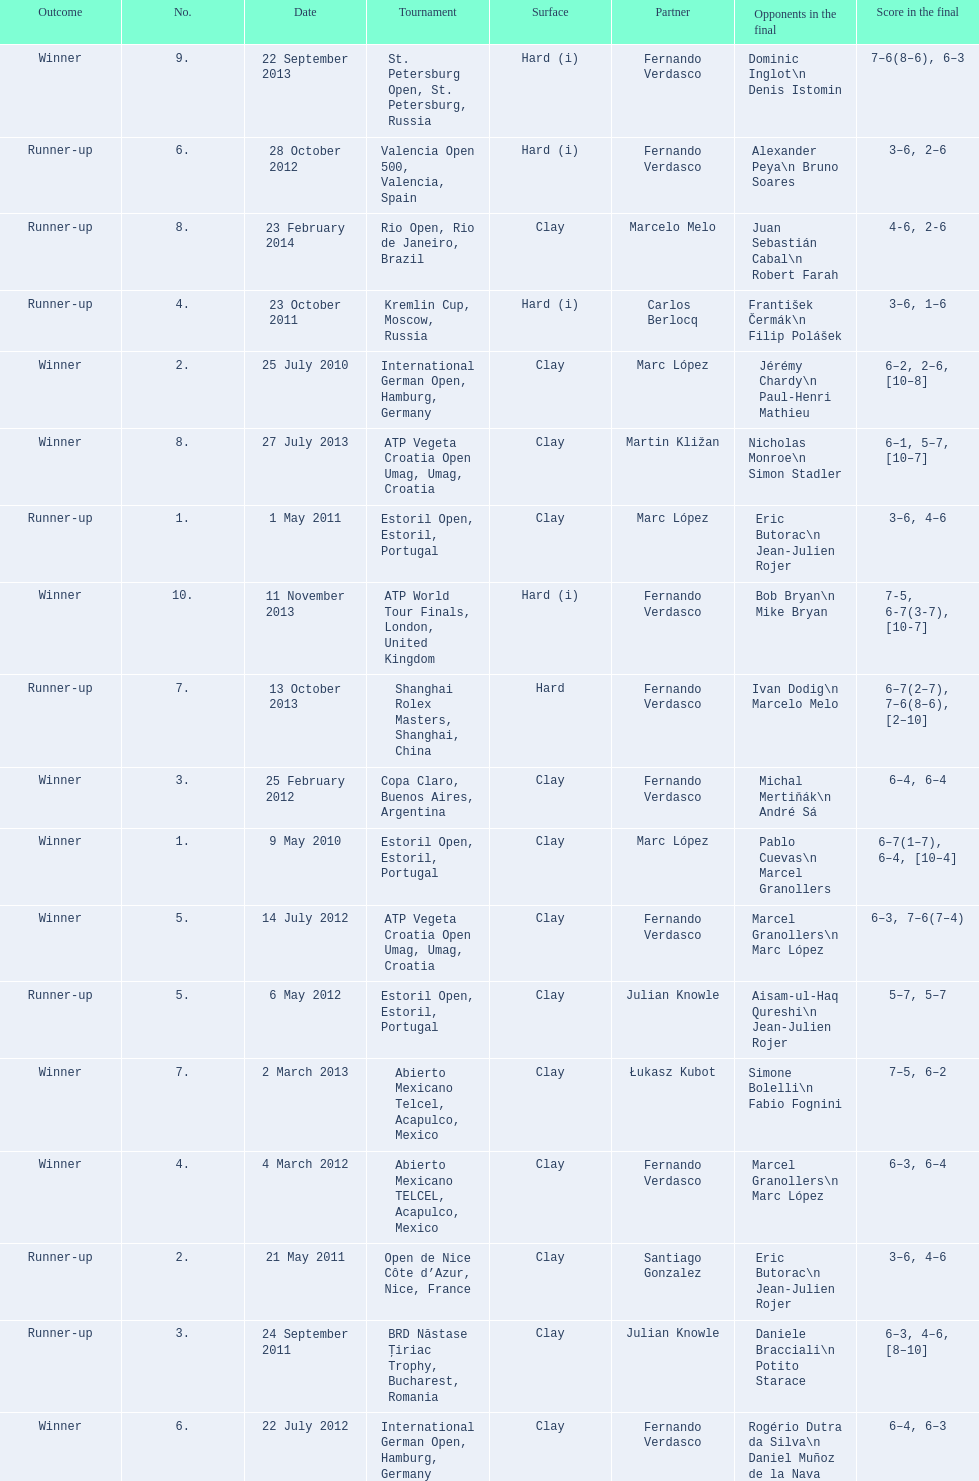What tournament was played after the kremlin cup? Copa Claro, Buenos Aires, Argentina. 